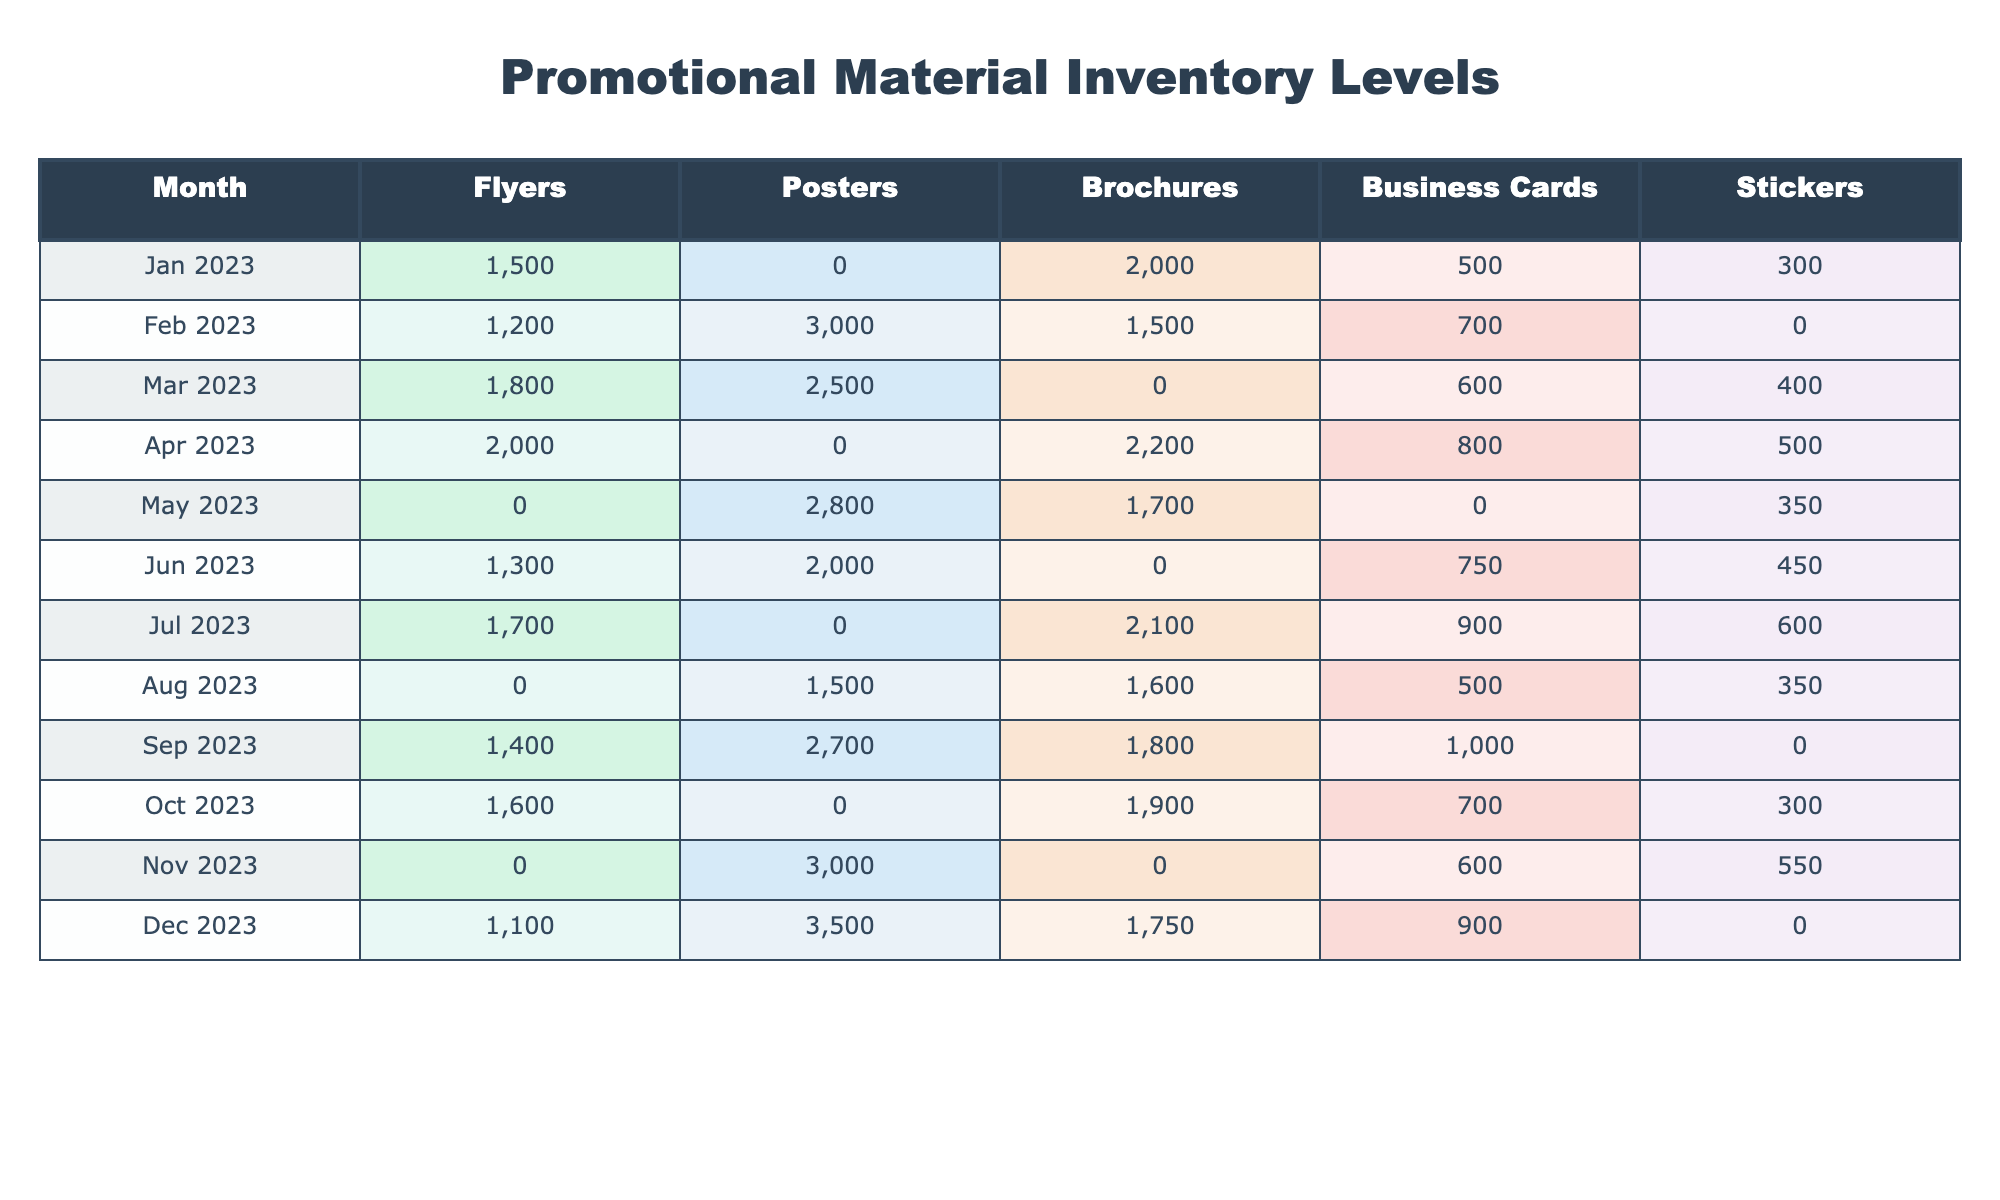What was the highest inventory level of stickers in a single month? The highest inventory level of stickers is found in January 2023 with 300 units. By reviewing the row for January, I can see the count for stickers.
Answer: 300 Which month had the lowest inventory of business cards? The month with the lowest inventory of business cards is March 2023, with 600 units. Scanning the business cards' column reveals that March has the minimum value.
Answer: 600 How many brochures were available in April 2023? In April 2023, the inventory for brochures was 2200 units. This information is directly taken from the brochures' column in the corresponding row for April.
Answer: 2200 What is the total number of flyers available from January to March 2023? To find the total flyers, sum up the inventory levels from January (1500), February (1200), and March (1800) which equals 1500 + 1200 + 1800 = 4500.
Answer: 4500 In which month was there no inventory of posters? There was no inventory of posters recorded in January 2023. Reviewing the table indicates that the value is missing for that month.
Answer: January 2023 How do the total monthly inventories of flyers compare between May and June 2023? The total flyers for May is 0 (since it is blank) and for June is 1300, so June has 1300 more flyers than May. This is calculated by directly accessing the values for both months and subtracting: 1300 - 0 = 1300.
Answer: June has 1300 more flyers What is the average inventory for brochures across the given months? To find the average, sum the brochure inventory levels: 2000 + 1500 + 2200 + 1700 + 1600 + 1800 + 1750 = 14550. There are 10 data points (but one month is missing, we ignore it), so the average is 14550 / 10 = 1455.
Answer: 1455 Were there any months where the inventory of business cards was higher than 900? Yes, in March and April 2023, the inventory levels of business cards were 1000 and 800, respectively. By checking the values, both March and April exceed the 900 mark.
Answer: Yes How many more posters were available in November compared to October 2023? There were 3000 posters in November and 0 in October, which means November had 3000 more posters. By calculating the difference, we see that 3000 - 0 = 3000.
Answer: 3000 Was January 2023 a month with a complete record for all types of promotional materials? No, January 2023 did not have a recorded value for posters, confirmed by checking the corresponding row for missing data.
Answer: No How does the total inventory in December compare to the total in September 2023? In September, the total inventory was 6400 (sum of all types), while in December it was 4250. Thus, September had a higher total of 2150 more. Calculation: 6400 - 4250 = 2150.
Answer: September had 2150 more 